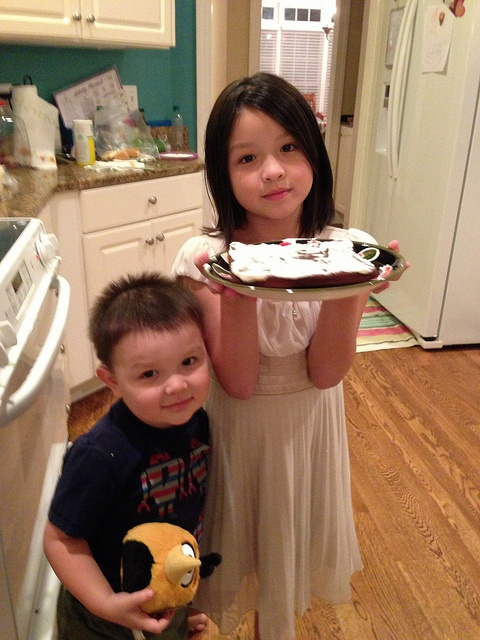Describe the objects in this image and their specific colors. I can see people in khaki, brown, black, and maroon tones, people in khaki, black, brown, and maroon tones, refrigerator in khaki and tan tones, oven in khaki, gray, tan, and ivory tones, and cake in khaki, white, maroon, black, and tan tones in this image. 